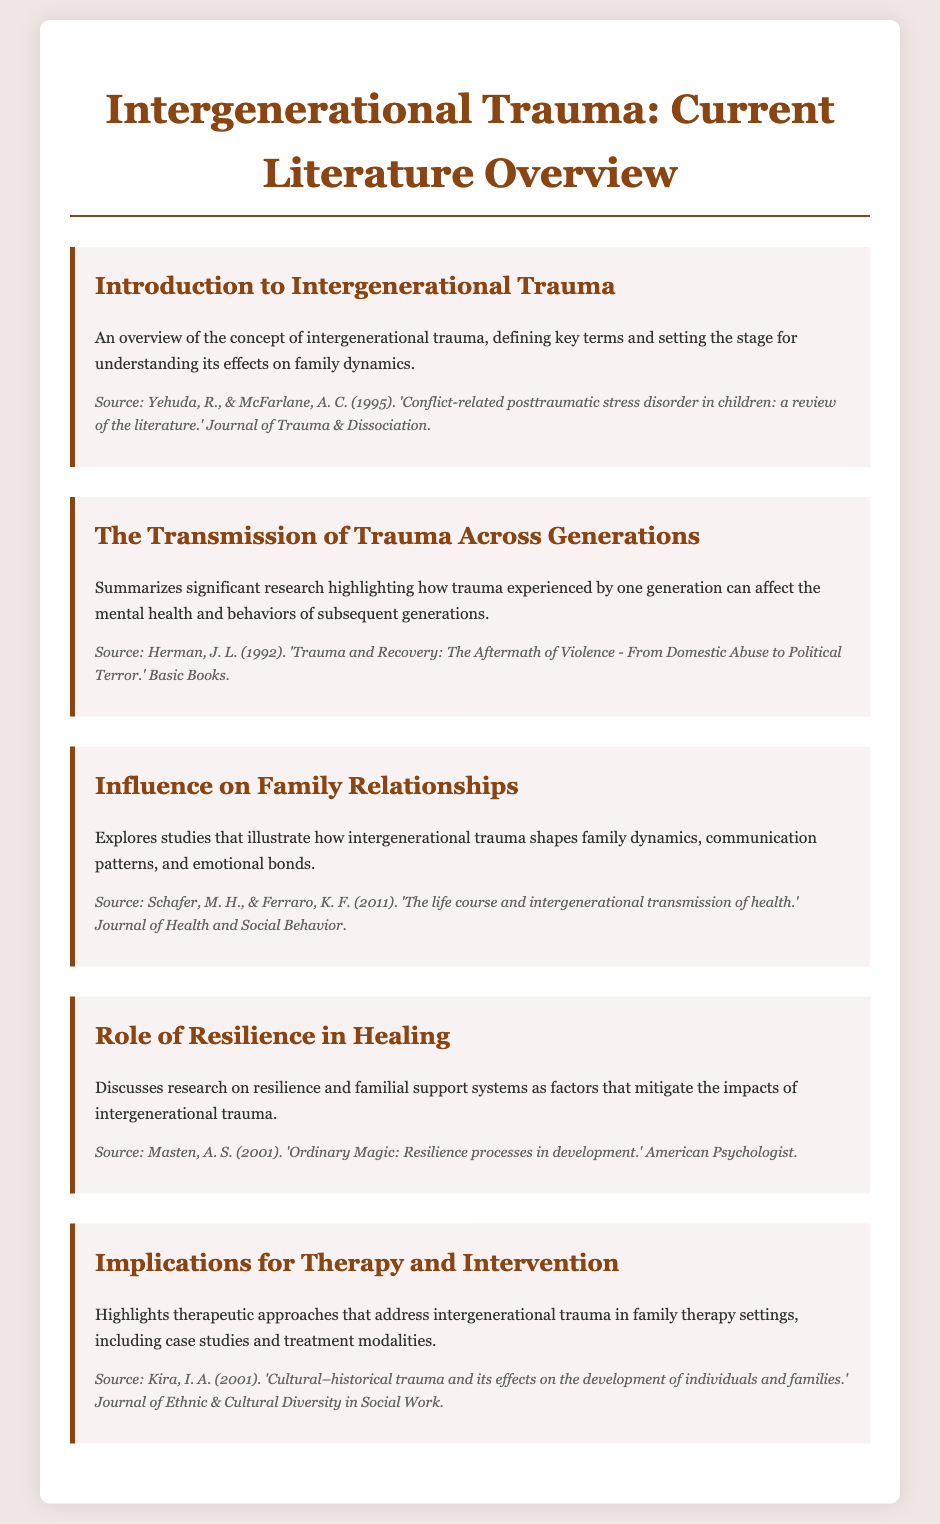What is the title of the document? The title is prominently displayed at the top of the rendered document.
Answer: Intergenerational Trauma: Current Literature Overview Who are the authors mentioned in the introduction section? The authors are cited in the source information for the introduction section.
Answer: Yehuda, R., & McFarlane, A. C What significant concept is summarized in the second menu item? The second menu item outlines the transmission of trauma and its effects.
Answer: Transmission of Trauma Across Generations Which study focuses on resilience processes in development? The source in the fourth menu item discusses resilience in the context of development.
Answer: Masten, A. S. (2001) How many menu items are listed in the document? The document contains a total of five distinct menu items for navigation.
Answer: Five 